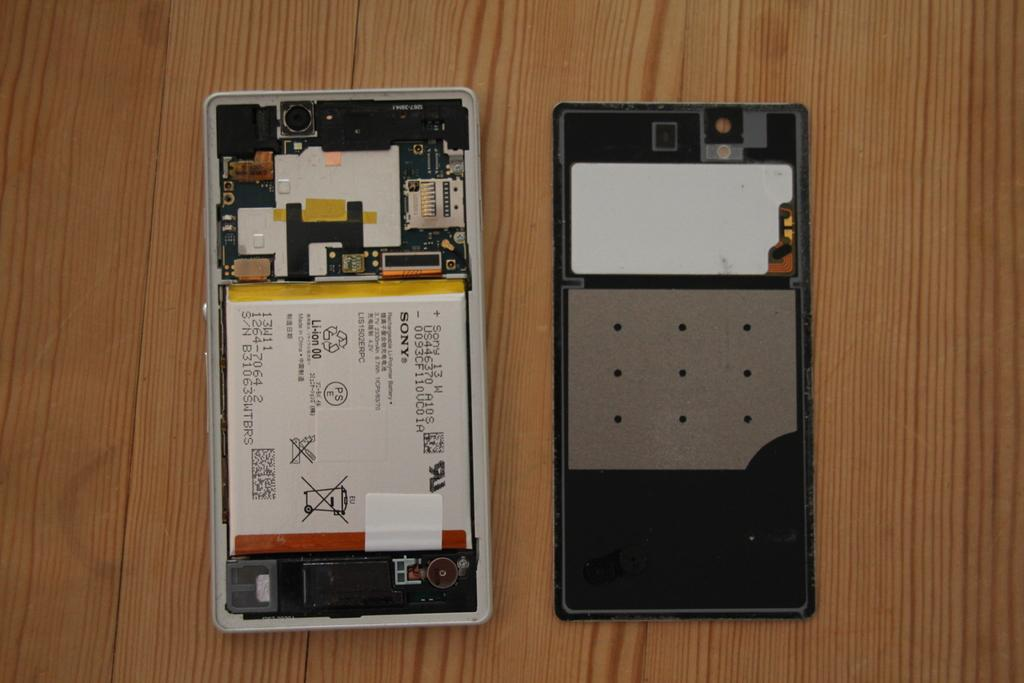<image>
Create a compact narrative representing the image presented. A cellphone is opened up revealing its insides, and a battery pack made by Sony. 